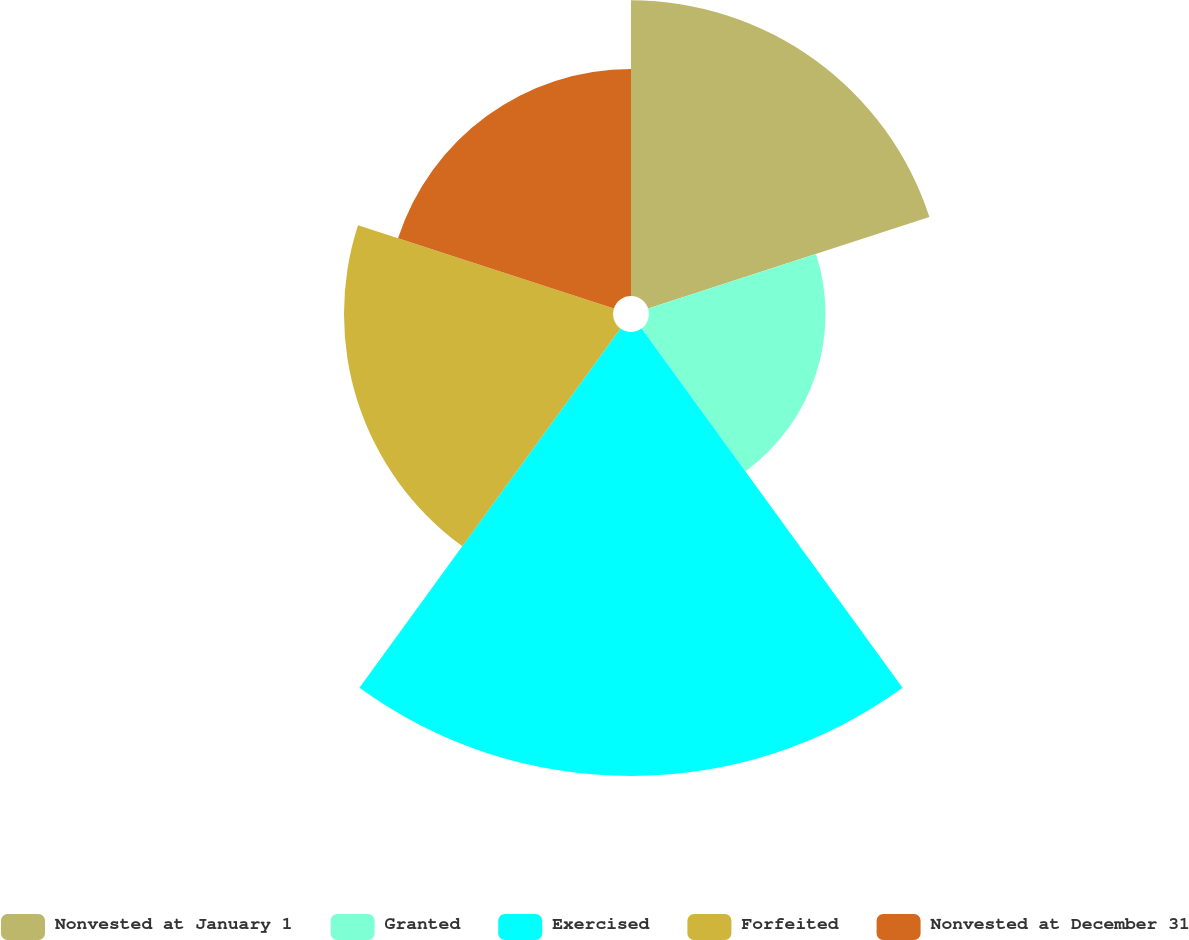Convert chart. <chart><loc_0><loc_0><loc_500><loc_500><pie_chart><fcel>Nonvested at January 1<fcel>Granted<fcel>Exercised<fcel>Forfeited<fcel>Nonvested at December 31<nl><fcel>20.94%<fcel>12.5%<fcel>31.44%<fcel>19.05%<fcel>16.07%<nl></chart> 